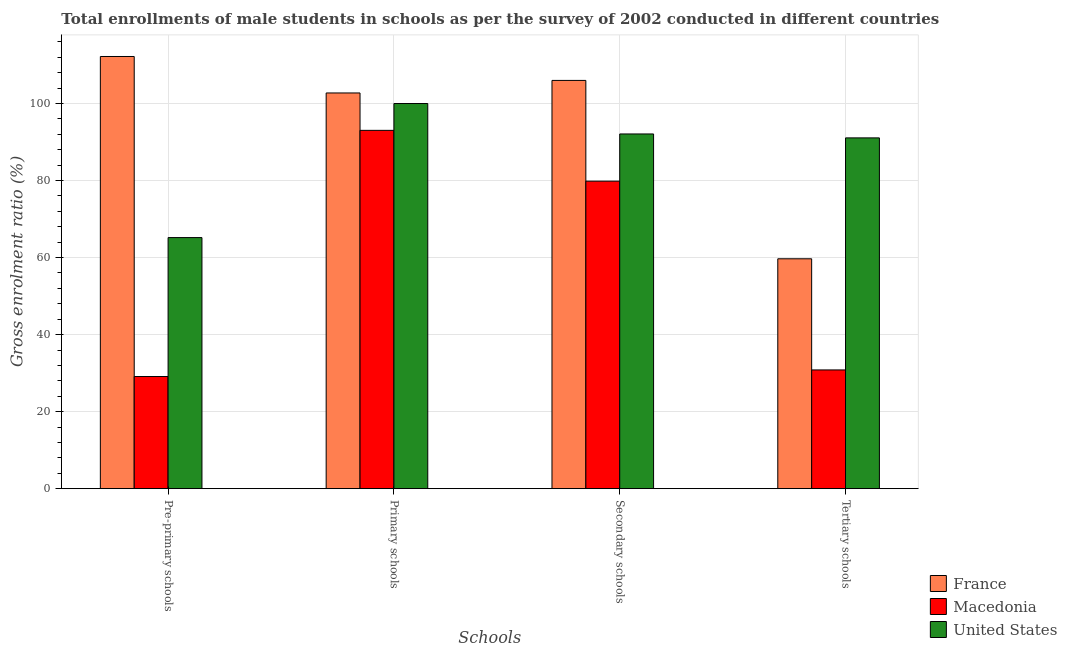How many bars are there on the 2nd tick from the right?
Make the answer very short. 3. What is the label of the 3rd group of bars from the left?
Make the answer very short. Secondary schools. What is the gross enrolment ratio(male) in tertiary schools in Macedonia?
Provide a short and direct response. 30.83. Across all countries, what is the maximum gross enrolment ratio(male) in primary schools?
Your answer should be compact. 102.74. Across all countries, what is the minimum gross enrolment ratio(male) in tertiary schools?
Keep it short and to the point. 30.83. In which country was the gross enrolment ratio(male) in primary schools maximum?
Give a very brief answer. France. In which country was the gross enrolment ratio(male) in pre-primary schools minimum?
Offer a terse response. Macedonia. What is the total gross enrolment ratio(male) in pre-primary schools in the graph?
Keep it short and to the point. 206.51. What is the difference between the gross enrolment ratio(male) in secondary schools in Macedonia and that in United States?
Your response must be concise. -12.25. What is the difference between the gross enrolment ratio(male) in pre-primary schools in France and the gross enrolment ratio(male) in tertiary schools in United States?
Make the answer very short. 21.13. What is the average gross enrolment ratio(male) in pre-primary schools per country?
Ensure brevity in your answer.  68.84. What is the difference between the gross enrolment ratio(male) in primary schools and gross enrolment ratio(male) in secondary schools in Macedonia?
Make the answer very short. 13.19. In how many countries, is the gross enrolment ratio(male) in primary schools greater than 28 %?
Provide a succinct answer. 3. What is the ratio of the gross enrolment ratio(male) in pre-primary schools in France to that in United States?
Your response must be concise. 1.72. Is the difference between the gross enrolment ratio(male) in pre-primary schools in France and Macedonia greater than the difference between the gross enrolment ratio(male) in secondary schools in France and Macedonia?
Give a very brief answer. Yes. What is the difference between the highest and the second highest gross enrolment ratio(male) in primary schools?
Your response must be concise. 2.74. What is the difference between the highest and the lowest gross enrolment ratio(male) in tertiary schools?
Keep it short and to the point. 60.24. Is it the case that in every country, the sum of the gross enrolment ratio(male) in pre-primary schools and gross enrolment ratio(male) in primary schools is greater than the sum of gross enrolment ratio(male) in secondary schools and gross enrolment ratio(male) in tertiary schools?
Make the answer very short. No. How many bars are there?
Your answer should be compact. 12. Are all the bars in the graph horizontal?
Your answer should be very brief. No. How many countries are there in the graph?
Keep it short and to the point. 3. What is the difference between two consecutive major ticks on the Y-axis?
Offer a very short reply. 20. Does the graph contain any zero values?
Make the answer very short. No. Does the graph contain grids?
Your answer should be compact. Yes. Where does the legend appear in the graph?
Provide a succinct answer. Bottom right. How are the legend labels stacked?
Offer a very short reply. Vertical. What is the title of the graph?
Offer a very short reply. Total enrollments of male students in schools as per the survey of 2002 conducted in different countries. Does "Colombia" appear as one of the legend labels in the graph?
Offer a very short reply. No. What is the label or title of the X-axis?
Ensure brevity in your answer.  Schools. What is the Gross enrolment ratio (%) of France in Pre-primary schools?
Your answer should be compact. 112.21. What is the Gross enrolment ratio (%) in Macedonia in Pre-primary schools?
Keep it short and to the point. 29.12. What is the Gross enrolment ratio (%) in United States in Pre-primary schools?
Make the answer very short. 65.19. What is the Gross enrolment ratio (%) in France in Primary schools?
Ensure brevity in your answer.  102.74. What is the Gross enrolment ratio (%) in Macedonia in Primary schools?
Offer a very short reply. 93.03. What is the Gross enrolment ratio (%) of United States in Primary schools?
Offer a terse response. 99.99. What is the Gross enrolment ratio (%) of France in Secondary schools?
Provide a short and direct response. 106. What is the Gross enrolment ratio (%) in Macedonia in Secondary schools?
Your answer should be very brief. 79.84. What is the Gross enrolment ratio (%) in United States in Secondary schools?
Ensure brevity in your answer.  92.09. What is the Gross enrolment ratio (%) of France in Tertiary schools?
Your answer should be very brief. 59.68. What is the Gross enrolment ratio (%) in Macedonia in Tertiary schools?
Give a very brief answer. 30.83. What is the Gross enrolment ratio (%) of United States in Tertiary schools?
Your answer should be compact. 91.07. Across all Schools, what is the maximum Gross enrolment ratio (%) of France?
Keep it short and to the point. 112.21. Across all Schools, what is the maximum Gross enrolment ratio (%) of Macedonia?
Offer a terse response. 93.03. Across all Schools, what is the maximum Gross enrolment ratio (%) in United States?
Your answer should be very brief. 99.99. Across all Schools, what is the minimum Gross enrolment ratio (%) in France?
Offer a terse response. 59.68. Across all Schools, what is the minimum Gross enrolment ratio (%) in Macedonia?
Your response must be concise. 29.12. Across all Schools, what is the minimum Gross enrolment ratio (%) in United States?
Provide a succinct answer. 65.19. What is the total Gross enrolment ratio (%) in France in the graph?
Your answer should be compact. 380.62. What is the total Gross enrolment ratio (%) of Macedonia in the graph?
Offer a very short reply. 232.82. What is the total Gross enrolment ratio (%) of United States in the graph?
Your response must be concise. 348.34. What is the difference between the Gross enrolment ratio (%) in France in Pre-primary schools and that in Primary schools?
Offer a very short reply. 9.47. What is the difference between the Gross enrolment ratio (%) in Macedonia in Pre-primary schools and that in Primary schools?
Offer a very short reply. -63.91. What is the difference between the Gross enrolment ratio (%) in United States in Pre-primary schools and that in Primary schools?
Provide a succinct answer. -34.81. What is the difference between the Gross enrolment ratio (%) in France in Pre-primary schools and that in Secondary schools?
Provide a short and direct response. 6.21. What is the difference between the Gross enrolment ratio (%) of Macedonia in Pre-primary schools and that in Secondary schools?
Your response must be concise. -50.72. What is the difference between the Gross enrolment ratio (%) in United States in Pre-primary schools and that in Secondary schools?
Give a very brief answer. -26.9. What is the difference between the Gross enrolment ratio (%) in France in Pre-primary schools and that in Tertiary schools?
Your response must be concise. 52.52. What is the difference between the Gross enrolment ratio (%) of Macedonia in Pre-primary schools and that in Tertiary schools?
Give a very brief answer. -1.71. What is the difference between the Gross enrolment ratio (%) in United States in Pre-primary schools and that in Tertiary schools?
Ensure brevity in your answer.  -25.88. What is the difference between the Gross enrolment ratio (%) of France in Primary schools and that in Secondary schools?
Provide a succinct answer. -3.26. What is the difference between the Gross enrolment ratio (%) of Macedonia in Primary schools and that in Secondary schools?
Ensure brevity in your answer.  13.19. What is the difference between the Gross enrolment ratio (%) of United States in Primary schools and that in Secondary schools?
Your response must be concise. 7.9. What is the difference between the Gross enrolment ratio (%) in France in Primary schools and that in Tertiary schools?
Keep it short and to the point. 43.05. What is the difference between the Gross enrolment ratio (%) of Macedonia in Primary schools and that in Tertiary schools?
Give a very brief answer. 62.2. What is the difference between the Gross enrolment ratio (%) in United States in Primary schools and that in Tertiary schools?
Make the answer very short. 8.92. What is the difference between the Gross enrolment ratio (%) of France in Secondary schools and that in Tertiary schools?
Your response must be concise. 46.31. What is the difference between the Gross enrolment ratio (%) of Macedonia in Secondary schools and that in Tertiary schools?
Your answer should be very brief. 49.01. What is the difference between the Gross enrolment ratio (%) in United States in Secondary schools and that in Tertiary schools?
Your answer should be very brief. 1.02. What is the difference between the Gross enrolment ratio (%) in France in Pre-primary schools and the Gross enrolment ratio (%) in Macedonia in Primary schools?
Keep it short and to the point. 19.18. What is the difference between the Gross enrolment ratio (%) in France in Pre-primary schools and the Gross enrolment ratio (%) in United States in Primary schools?
Provide a succinct answer. 12.21. What is the difference between the Gross enrolment ratio (%) of Macedonia in Pre-primary schools and the Gross enrolment ratio (%) of United States in Primary schools?
Offer a terse response. -70.87. What is the difference between the Gross enrolment ratio (%) of France in Pre-primary schools and the Gross enrolment ratio (%) of Macedonia in Secondary schools?
Make the answer very short. 32.37. What is the difference between the Gross enrolment ratio (%) of France in Pre-primary schools and the Gross enrolment ratio (%) of United States in Secondary schools?
Your answer should be very brief. 20.11. What is the difference between the Gross enrolment ratio (%) of Macedonia in Pre-primary schools and the Gross enrolment ratio (%) of United States in Secondary schools?
Your answer should be compact. -62.97. What is the difference between the Gross enrolment ratio (%) of France in Pre-primary schools and the Gross enrolment ratio (%) of Macedonia in Tertiary schools?
Give a very brief answer. 81.38. What is the difference between the Gross enrolment ratio (%) in France in Pre-primary schools and the Gross enrolment ratio (%) in United States in Tertiary schools?
Provide a short and direct response. 21.13. What is the difference between the Gross enrolment ratio (%) in Macedonia in Pre-primary schools and the Gross enrolment ratio (%) in United States in Tertiary schools?
Offer a terse response. -61.95. What is the difference between the Gross enrolment ratio (%) of France in Primary schools and the Gross enrolment ratio (%) of Macedonia in Secondary schools?
Give a very brief answer. 22.9. What is the difference between the Gross enrolment ratio (%) of France in Primary schools and the Gross enrolment ratio (%) of United States in Secondary schools?
Give a very brief answer. 10.64. What is the difference between the Gross enrolment ratio (%) of Macedonia in Primary schools and the Gross enrolment ratio (%) of United States in Secondary schools?
Your response must be concise. 0.94. What is the difference between the Gross enrolment ratio (%) in France in Primary schools and the Gross enrolment ratio (%) in Macedonia in Tertiary schools?
Your answer should be compact. 71.91. What is the difference between the Gross enrolment ratio (%) of France in Primary schools and the Gross enrolment ratio (%) of United States in Tertiary schools?
Your answer should be very brief. 11.66. What is the difference between the Gross enrolment ratio (%) in Macedonia in Primary schools and the Gross enrolment ratio (%) in United States in Tertiary schools?
Your answer should be very brief. 1.96. What is the difference between the Gross enrolment ratio (%) in France in Secondary schools and the Gross enrolment ratio (%) in Macedonia in Tertiary schools?
Keep it short and to the point. 75.17. What is the difference between the Gross enrolment ratio (%) of France in Secondary schools and the Gross enrolment ratio (%) of United States in Tertiary schools?
Your answer should be very brief. 14.92. What is the difference between the Gross enrolment ratio (%) of Macedonia in Secondary schools and the Gross enrolment ratio (%) of United States in Tertiary schools?
Your response must be concise. -11.23. What is the average Gross enrolment ratio (%) in France per Schools?
Offer a very short reply. 95.16. What is the average Gross enrolment ratio (%) in Macedonia per Schools?
Make the answer very short. 58.2. What is the average Gross enrolment ratio (%) of United States per Schools?
Your response must be concise. 87.09. What is the difference between the Gross enrolment ratio (%) of France and Gross enrolment ratio (%) of Macedonia in Pre-primary schools?
Your answer should be very brief. 83.09. What is the difference between the Gross enrolment ratio (%) in France and Gross enrolment ratio (%) in United States in Pre-primary schools?
Ensure brevity in your answer.  47.02. What is the difference between the Gross enrolment ratio (%) in Macedonia and Gross enrolment ratio (%) in United States in Pre-primary schools?
Keep it short and to the point. -36.07. What is the difference between the Gross enrolment ratio (%) of France and Gross enrolment ratio (%) of Macedonia in Primary schools?
Provide a short and direct response. 9.71. What is the difference between the Gross enrolment ratio (%) of France and Gross enrolment ratio (%) of United States in Primary schools?
Your answer should be compact. 2.74. What is the difference between the Gross enrolment ratio (%) in Macedonia and Gross enrolment ratio (%) in United States in Primary schools?
Keep it short and to the point. -6.96. What is the difference between the Gross enrolment ratio (%) in France and Gross enrolment ratio (%) in Macedonia in Secondary schools?
Make the answer very short. 26.16. What is the difference between the Gross enrolment ratio (%) in France and Gross enrolment ratio (%) in United States in Secondary schools?
Provide a short and direct response. 13.9. What is the difference between the Gross enrolment ratio (%) of Macedonia and Gross enrolment ratio (%) of United States in Secondary schools?
Provide a short and direct response. -12.25. What is the difference between the Gross enrolment ratio (%) of France and Gross enrolment ratio (%) of Macedonia in Tertiary schools?
Offer a terse response. 28.85. What is the difference between the Gross enrolment ratio (%) of France and Gross enrolment ratio (%) of United States in Tertiary schools?
Keep it short and to the point. -31.39. What is the difference between the Gross enrolment ratio (%) of Macedonia and Gross enrolment ratio (%) of United States in Tertiary schools?
Give a very brief answer. -60.24. What is the ratio of the Gross enrolment ratio (%) of France in Pre-primary schools to that in Primary schools?
Your response must be concise. 1.09. What is the ratio of the Gross enrolment ratio (%) in Macedonia in Pre-primary schools to that in Primary schools?
Give a very brief answer. 0.31. What is the ratio of the Gross enrolment ratio (%) in United States in Pre-primary schools to that in Primary schools?
Offer a very short reply. 0.65. What is the ratio of the Gross enrolment ratio (%) in France in Pre-primary schools to that in Secondary schools?
Offer a terse response. 1.06. What is the ratio of the Gross enrolment ratio (%) in Macedonia in Pre-primary schools to that in Secondary schools?
Your answer should be compact. 0.36. What is the ratio of the Gross enrolment ratio (%) of United States in Pre-primary schools to that in Secondary schools?
Your answer should be very brief. 0.71. What is the ratio of the Gross enrolment ratio (%) in France in Pre-primary schools to that in Tertiary schools?
Your answer should be very brief. 1.88. What is the ratio of the Gross enrolment ratio (%) in Macedonia in Pre-primary schools to that in Tertiary schools?
Your answer should be compact. 0.94. What is the ratio of the Gross enrolment ratio (%) in United States in Pre-primary schools to that in Tertiary schools?
Offer a terse response. 0.72. What is the ratio of the Gross enrolment ratio (%) in France in Primary schools to that in Secondary schools?
Provide a succinct answer. 0.97. What is the ratio of the Gross enrolment ratio (%) in Macedonia in Primary schools to that in Secondary schools?
Your answer should be very brief. 1.17. What is the ratio of the Gross enrolment ratio (%) of United States in Primary schools to that in Secondary schools?
Keep it short and to the point. 1.09. What is the ratio of the Gross enrolment ratio (%) in France in Primary schools to that in Tertiary schools?
Make the answer very short. 1.72. What is the ratio of the Gross enrolment ratio (%) of Macedonia in Primary schools to that in Tertiary schools?
Keep it short and to the point. 3.02. What is the ratio of the Gross enrolment ratio (%) of United States in Primary schools to that in Tertiary schools?
Your answer should be very brief. 1.1. What is the ratio of the Gross enrolment ratio (%) in France in Secondary schools to that in Tertiary schools?
Your answer should be very brief. 1.78. What is the ratio of the Gross enrolment ratio (%) of Macedonia in Secondary schools to that in Tertiary schools?
Your answer should be very brief. 2.59. What is the ratio of the Gross enrolment ratio (%) in United States in Secondary schools to that in Tertiary schools?
Offer a terse response. 1.01. What is the difference between the highest and the second highest Gross enrolment ratio (%) of France?
Ensure brevity in your answer.  6.21. What is the difference between the highest and the second highest Gross enrolment ratio (%) in Macedonia?
Provide a short and direct response. 13.19. What is the difference between the highest and the second highest Gross enrolment ratio (%) in United States?
Ensure brevity in your answer.  7.9. What is the difference between the highest and the lowest Gross enrolment ratio (%) of France?
Keep it short and to the point. 52.52. What is the difference between the highest and the lowest Gross enrolment ratio (%) of Macedonia?
Your response must be concise. 63.91. What is the difference between the highest and the lowest Gross enrolment ratio (%) in United States?
Your response must be concise. 34.81. 